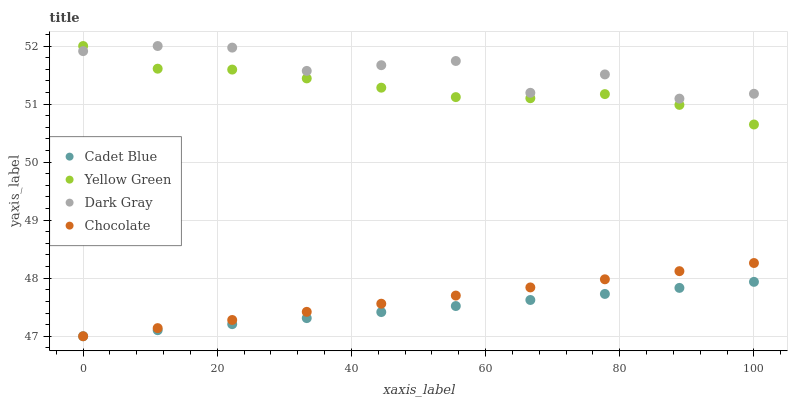Does Cadet Blue have the minimum area under the curve?
Answer yes or no. Yes. Does Dark Gray have the maximum area under the curve?
Answer yes or no. Yes. Does Yellow Green have the minimum area under the curve?
Answer yes or no. No. Does Yellow Green have the maximum area under the curve?
Answer yes or no. No. Is Cadet Blue the smoothest?
Answer yes or no. Yes. Is Dark Gray the roughest?
Answer yes or no. Yes. Is Yellow Green the smoothest?
Answer yes or no. No. Is Yellow Green the roughest?
Answer yes or no. No. Does Cadet Blue have the lowest value?
Answer yes or no. Yes. Does Yellow Green have the lowest value?
Answer yes or no. No. Does Yellow Green have the highest value?
Answer yes or no. Yes. Does Cadet Blue have the highest value?
Answer yes or no. No. Is Chocolate less than Dark Gray?
Answer yes or no. Yes. Is Yellow Green greater than Cadet Blue?
Answer yes or no. Yes. Does Dark Gray intersect Yellow Green?
Answer yes or no. Yes. Is Dark Gray less than Yellow Green?
Answer yes or no. No. Is Dark Gray greater than Yellow Green?
Answer yes or no. No. Does Chocolate intersect Dark Gray?
Answer yes or no. No. 